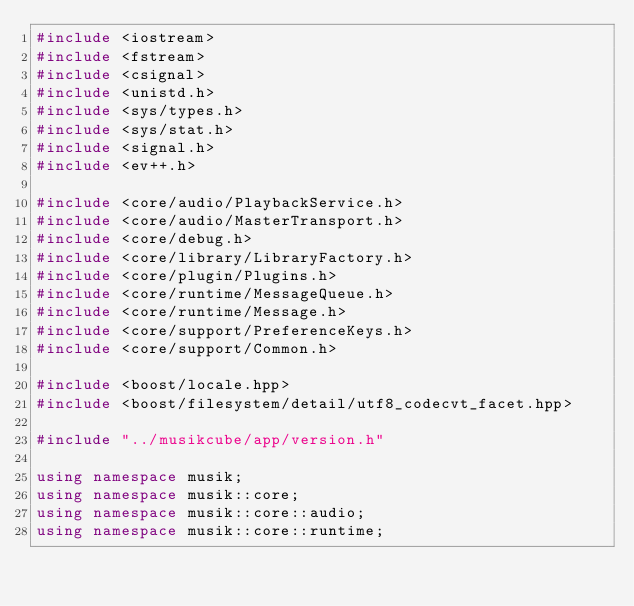<code> <loc_0><loc_0><loc_500><loc_500><_C++_>#include <iostream>
#include <fstream>
#include <csignal>
#include <unistd.h>
#include <sys/types.h>
#include <sys/stat.h>
#include <signal.h>
#include <ev++.h>

#include <core/audio/PlaybackService.h>
#include <core/audio/MasterTransport.h>
#include <core/debug.h>
#include <core/library/LibraryFactory.h>
#include <core/plugin/Plugins.h>
#include <core/runtime/MessageQueue.h>
#include <core/runtime/Message.h>
#include <core/support/PreferenceKeys.h>
#include <core/support/Common.h>

#include <boost/locale.hpp>
#include <boost/filesystem/detail/utf8_codecvt_facet.hpp>

#include "../musikcube/app/version.h"

using namespace musik;
using namespace musik::core;
using namespace musik::core::audio;
using namespace musik::core::runtime;
</code> 